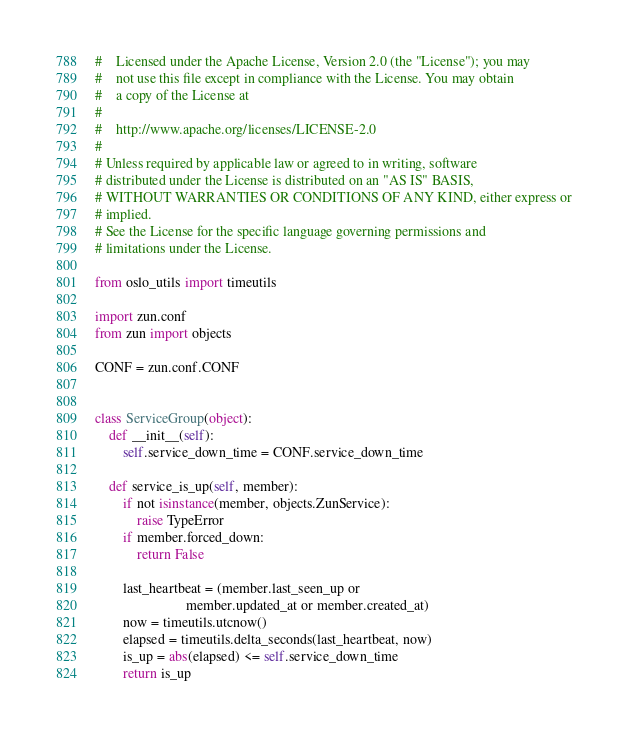<code> <loc_0><loc_0><loc_500><loc_500><_Python_>#    Licensed under the Apache License, Version 2.0 (the "License"); you may
#    not use this file except in compliance with the License. You may obtain
#    a copy of the License at
#
#    http://www.apache.org/licenses/LICENSE-2.0
#
# Unless required by applicable law or agreed to in writing, software
# distributed under the License is distributed on an "AS IS" BASIS,
# WITHOUT WARRANTIES OR CONDITIONS OF ANY KIND, either express or
# implied.
# See the License for the specific language governing permissions and
# limitations under the License.

from oslo_utils import timeutils

import zun.conf
from zun import objects

CONF = zun.conf.CONF


class ServiceGroup(object):
    def __init__(self):
        self.service_down_time = CONF.service_down_time

    def service_is_up(self, member):
        if not isinstance(member, objects.ZunService):
            raise TypeError
        if member.forced_down:
            return False

        last_heartbeat = (member.last_seen_up or
                          member.updated_at or member.created_at)
        now = timeutils.utcnow()
        elapsed = timeutils.delta_seconds(last_heartbeat, now)
        is_up = abs(elapsed) <= self.service_down_time
        return is_up
</code> 